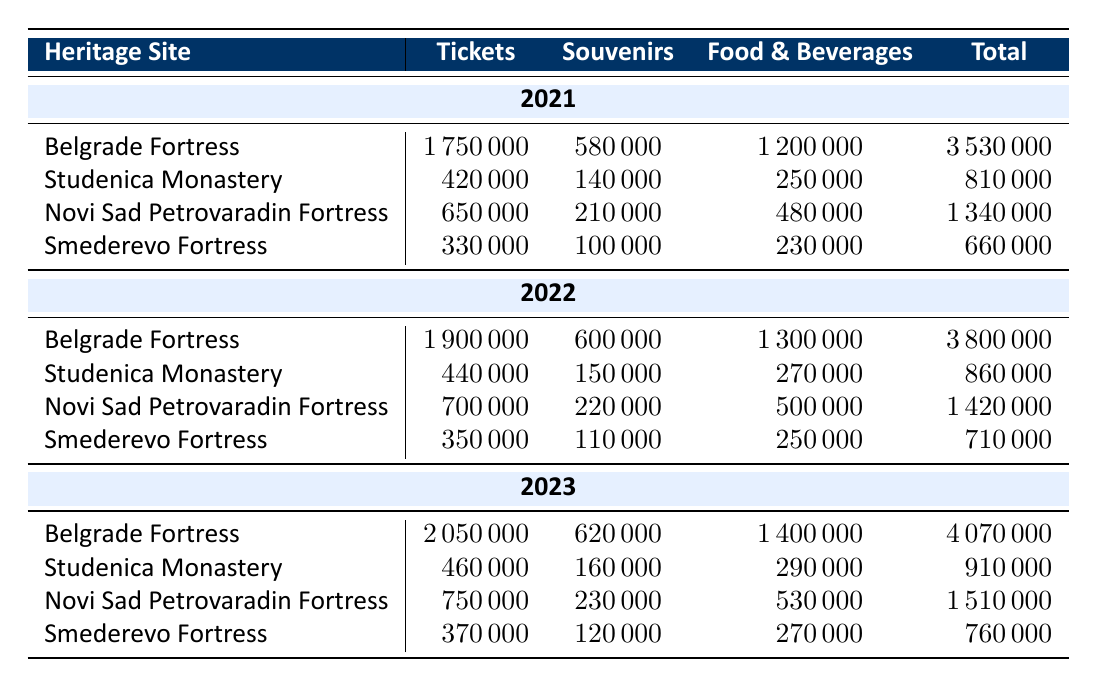What is the total visitor spending for Belgrade Fortress in 2022? The table shows that for Belgrade Fortress in 2022, the total visitor spending is listed directly. Looking at the row for Belgrade Fortress under the year 2022, the total spending is 3800000.
Answer: 3800000 Which heritage site had the highest ticket sales in 2023? By examining the ticket sales for each site in 2023, the amounts are as follows: Belgrade Fortress has 2050000, Studenica Monastery has 460000, Novi Sad Petrovaradin Fortress has 750000, and Smederevo Fortress has 370000. The highest value among these is for Belgrade Fortress at 2050000.
Answer: Belgrade Fortress What was the percentage increase in total spending at Novi Sad Petrovaradin Fortress from 2022 to 2023? The total spending for Novi Sad Petrovaradin Fortress in 2022 was 1420000 and in 2023 it was 1510000. To find the percentage increase, first calculate the difference: 1510000 - 1420000 = 100000. Then divide this difference by the 2022 total: 100000 / 1420000 ≈ 0.0704. Finally, multiply by 100 to get the percentage: 0.0704 * 100 ≈ 7.04%.
Answer: 7.04% Did the total visitor spending at Studenica Monastery decrease from 2021 to 2023? The total spending for Studenica Monastery is 810000 in 2021, 860000 in 2022, and 910000 in 2023. Comparing these values: 810000 < 860000 < 910000 shows that the spending has increased every year. Thus, it did not decrease.
Answer: No What is the average spending on food and beverages across all sites in 2021? To find the average spending on food and beverages in 2021, we first identify the food and beverages spending for each site: Belgrade Fortress 1200000, Studenica Monastery 250000, Novi Sad Petrovaradin Fortress 480000, Smederevo Fortress 230000. Next, sum these values: 1200000 + 250000 + 480000 + 230000 = 2110000. Then divide by the number of sites (4): 2110000 / 4 = 527500.
Answer: 527500 